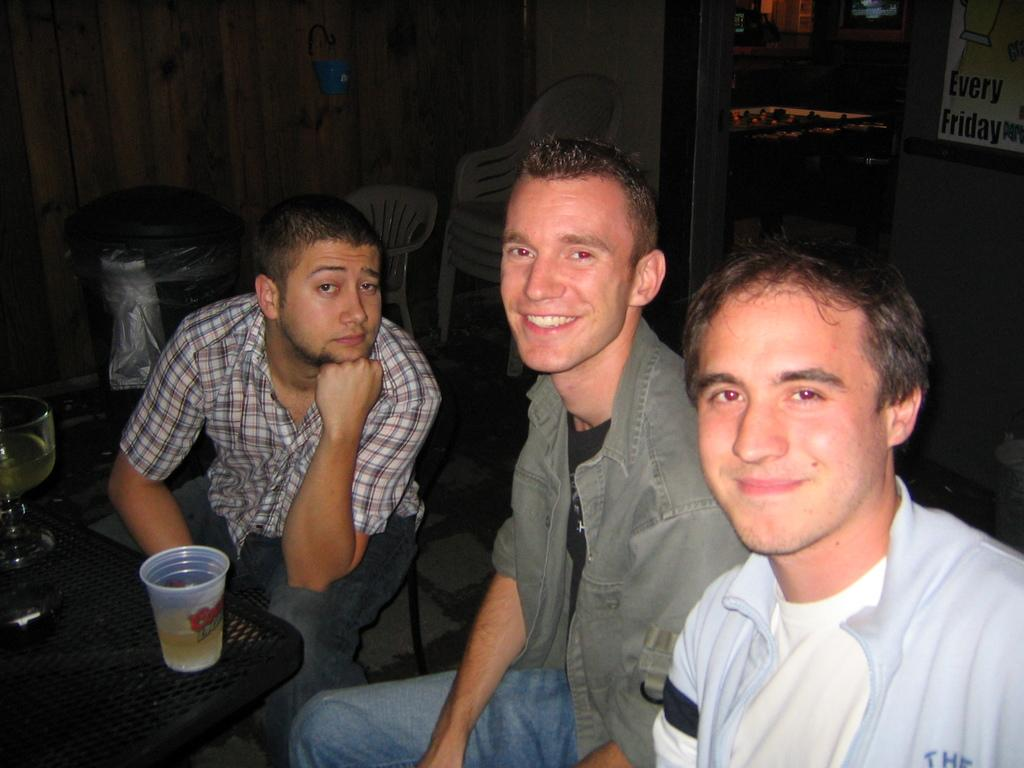How many people are present in the image? There are three people in the image. What is the facial expression of the people in the image? Two of the people are smiling. What type of furniture is in the image? There is a black table in the image. What objects are on the table? There are glasses on the table. What can be seen in the background of the image? There is a bin and a chair in the background. What is on the wall in the image? There is a banner on the wall. What type of alley can be seen behind the people in the image? There is no alley visible in the image; it takes place indoors. What emotion is expressed by the people in the image? The people are smiling, which typically indicates happiness or enjoyment, not disgust. 